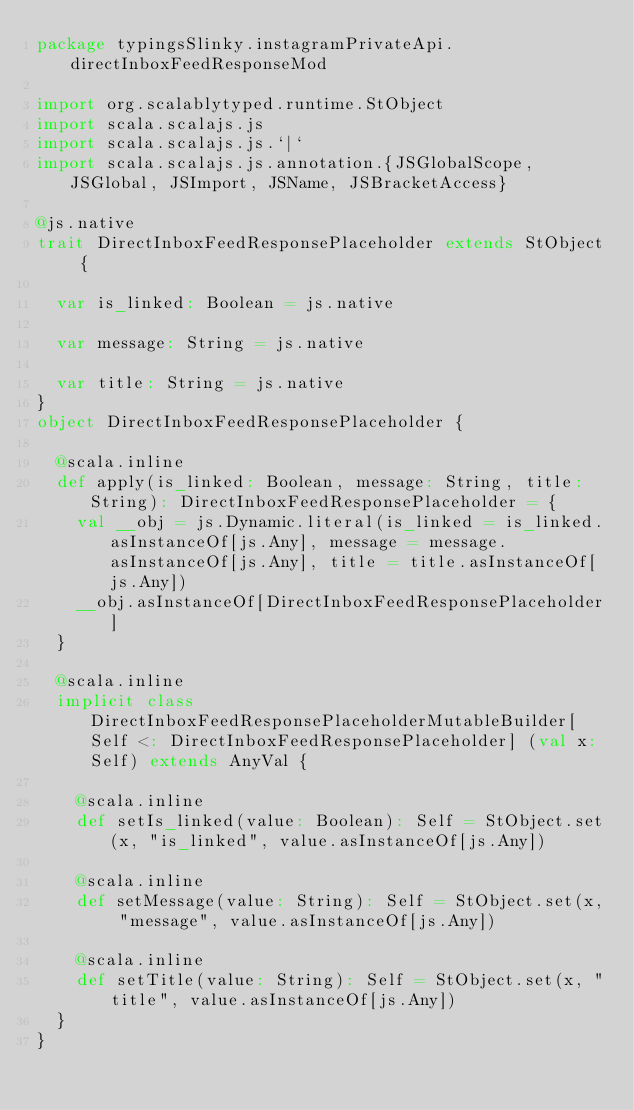<code> <loc_0><loc_0><loc_500><loc_500><_Scala_>package typingsSlinky.instagramPrivateApi.directInboxFeedResponseMod

import org.scalablytyped.runtime.StObject
import scala.scalajs.js
import scala.scalajs.js.`|`
import scala.scalajs.js.annotation.{JSGlobalScope, JSGlobal, JSImport, JSName, JSBracketAccess}

@js.native
trait DirectInboxFeedResponsePlaceholder extends StObject {
  
  var is_linked: Boolean = js.native
  
  var message: String = js.native
  
  var title: String = js.native
}
object DirectInboxFeedResponsePlaceholder {
  
  @scala.inline
  def apply(is_linked: Boolean, message: String, title: String): DirectInboxFeedResponsePlaceholder = {
    val __obj = js.Dynamic.literal(is_linked = is_linked.asInstanceOf[js.Any], message = message.asInstanceOf[js.Any], title = title.asInstanceOf[js.Any])
    __obj.asInstanceOf[DirectInboxFeedResponsePlaceholder]
  }
  
  @scala.inline
  implicit class DirectInboxFeedResponsePlaceholderMutableBuilder[Self <: DirectInboxFeedResponsePlaceholder] (val x: Self) extends AnyVal {
    
    @scala.inline
    def setIs_linked(value: Boolean): Self = StObject.set(x, "is_linked", value.asInstanceOf[js.Any])
    
    @scala.inline
    def setMessage(value: String): Self = StObject.set(x, "message", value.asInstanceOf[js.Any])
    
    @scala.inline
    def setTitle(value: String): Self = StObject.set(x, "title", value.asInstanceOf[js.Any])
  }
}
</code> 